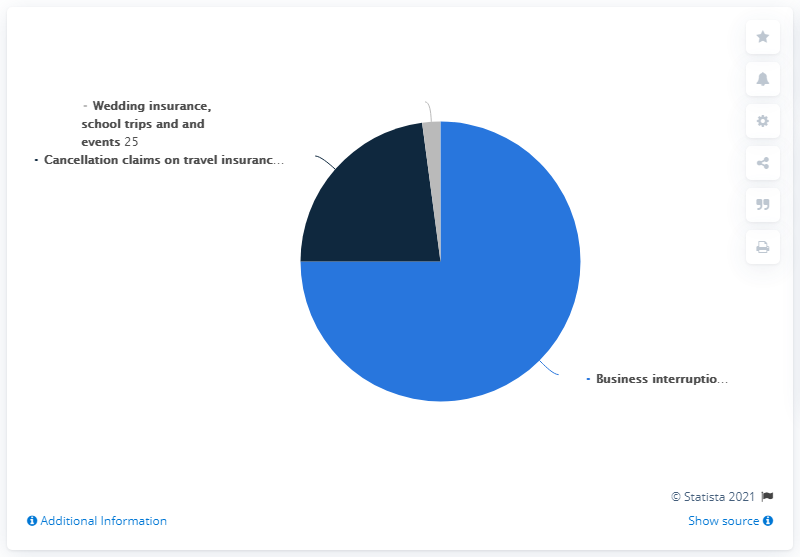Mention a couple of crucial points in this snapshot. The color of the largest pie is light blue. 